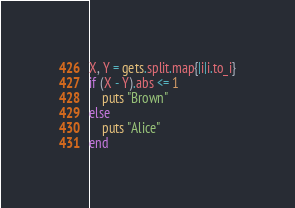<code> <loc_0><loc_0><loc_500><loc_500><_Ruby_>X, Y = gets.split.map{|i|i.to_i}
if (X - Y).abs <= 1
    puts "Brown"
else
    puts "Alice"
end
</code> 